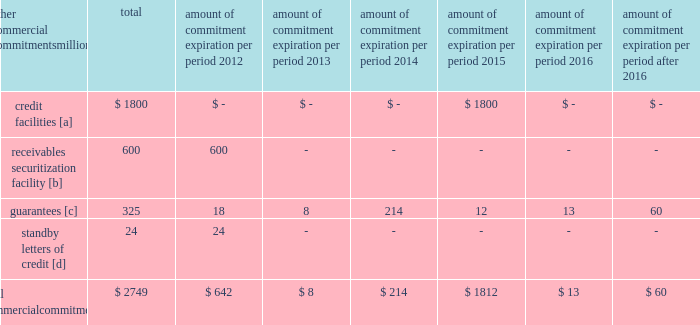Amount of commitment expiration per period other commercial commitments after millions total 2012 2013 2014 2015 2016 2016 .
[a] none of the credit facility was used as of december 31 , 2011 .
[b] $ 100 million of the receivables securitization facility was utilized at december 31 , 2011 , which is accounted for as debt .
The full program matures in august 2012 .
[c] includes guaranteed obligations related to our headquarters building , equipment financings , and affiliated operations .
[d] none of the letters of credit were drawn upon as of december 31 , 2011 .
Off-balance sheet arrangements guarantees 2013 at december 31 , 2011 , we were contingently liable for $ 325 million in guarantees .
We have recorded a liability of $ 3 million for the fair value of these obligations as of december 31 , 2011 and 2010 .
We entered into these contingent guarantees in the normal course of business , and they include guaranteed obligations related to our headquarters building , equipment financings , and affiliated operations .
The final guarantee expires in 2022 .
We are not aware of any existing event of default that would require us to satisfy these guarantees .
We do not expect that these guarantees will have a material adverse effect on our consolidated financial condition , results of operations , or liquidity .
Other matters labor agreements 2013 in january 2010 , the nation 2019s largest freight railroads began the current round of negotiations with the labor unions .
Generally , contract negotiations with the various unions take place over an extended period of time .
This round of negotiations was no exception .
In september 2011 , the rail industry reached agreements with the united transportation union .
On november 5 , 2011 , a presidential emergency board ( peb ) appointed by president obama issued recommendations to resolve the disputes between the u.s .
Railroads and 11 unions that had not yet reached agreements .
Since then , ten unions reached agreements with the railroads , all of them generally patterned on the recommendations of the peb , and the unions subsequently ratified these agreements .
The railroad industry reached a tentative agreement with the brotherhood of maintenance of way employees ( bmwe ) on february 2 , 2012 , eliminating the immediate threat of a national rail strike .
The bmwe now will commence ratification of this tentative agreement by its members .
Inflation 2013 long periods of inflation significantly increase asset replacement costs for capital-intensive companies .
As a result , assuming that we replace all operating assets at current price levels , depreciation charges ( on an inflation-adjusted basis ) would be substantially greater than historically reported amounts .
Derivative financial instruments 2013 we may use derivative financial instruments in limited instances to assist in managing our overall exposure to fluctuations in interest rates and fuel prices .
We are not a party to leveraged derivatives and , by policy , do not use derivative financial instruments for speculative purposes .
Derivative financial instruments qualifying for hedge accounting must maintain a specified level of effectiveness between the hedging instrument and the item being hedged , both at inception and throughout the hedged period .
We formally document the nature and relationships between the hedging instruments and hedged items at inception , as well as our risk-management objectives , strategies for undertaking the various hedge transactions , and method of assessing hedge effectiveness .
Changes in the fair market value of derivative financial instruments that do not qualify for hedge accounting are charged to earnings .
We may use swaps , collars , futures , and/or forward contracts to mitigate the risk of adverse movements in interest rates and fuel prices ; however , the use of these derivative financial instruments may limit future benefits from favorable price movements. .
How much of the receivables securitization facility was available at december 31 , 2011? 
Computations: ((600 - 100) * 1000000)
Answer: 500000000.0. 